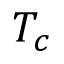<formula> <loc_0><loc_0><loc_500><loc_500>T _ { c }</formula> 